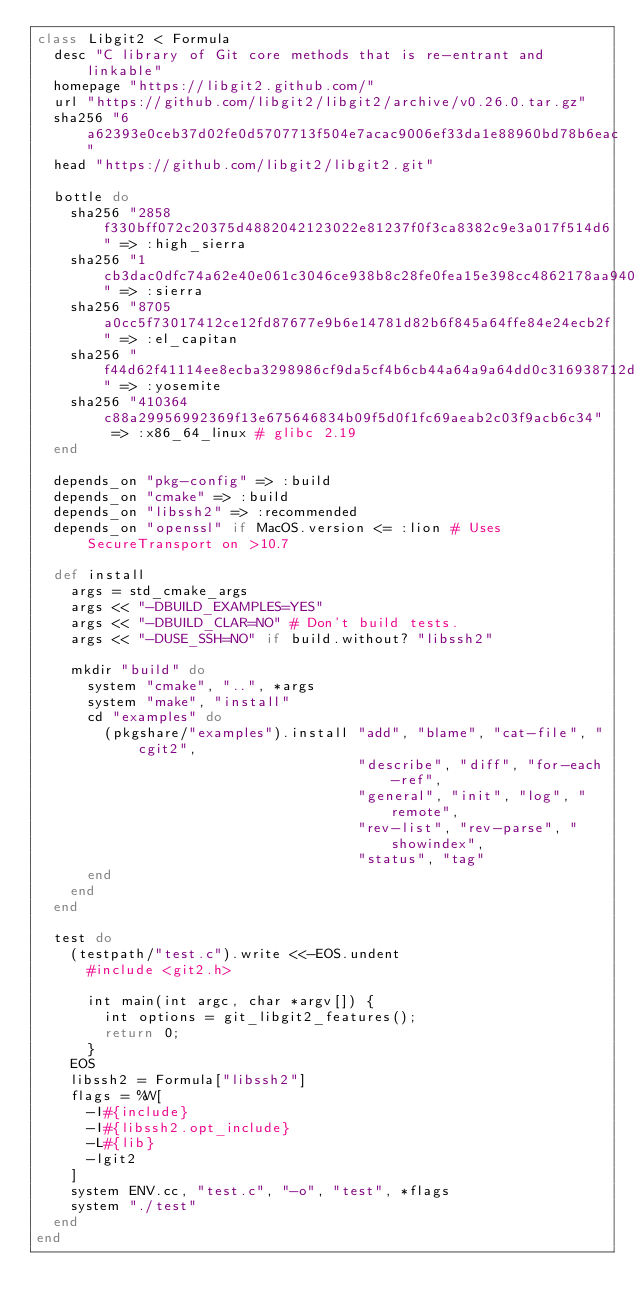Convert code to text. <code><loc_0><loc_0><loc_500><loc_500><_Ruby_>class Libgit2 < Formula
  desc "C library of Git core methods that is re-entrant and linkable"
  homepage "https://libgit2.github.com/"
  url "https://github.com/libgit2/libgit2/archive/v0.26.0.tar.gz"
  sha256 "6a62393e0ceb37d02fe0d5707713f504e7acac9006ef33da1e88960bd78b6eac"
  head "https://github.com/libgit2/libgit2.git"

  bottle do
    sha256 "2858f330bff072c20375d4882042123022e81237f0f3ca8382c9e3a017f514d6" => :high_sierra
    sha256 "1cb3dac0dfc74a62e40e061c3046ce938b8c28fe0fea15e398cc4862178aa940" => :sierra
    sha256 "8705a0cc5f73017412ce12fd87677e9b6e14781d82b6f845a64ffe84e24ecb2f" => :el_capitan
    sha256 "f44d62f41114ee8ecba3298986cf9da5cf4b6cb44a64a9a64dd0c316938712d1" => :yosemite
    sha256 "410364c88a29956992369f13e675646834b09f5d0f1fc69aeab2c03f9acb6c34" => :x86_64_linux # glibc 2.19
  end

  depends_on "pkg-config" => :build
  depends_on "cmake" => :build
  depends_on "libssh2" => :recommended
  depends_on "openssl" if MacOS.version <= :lion # Uses SecureTransport on >10.7

  def install
    args = std_cmake_args
    args << "-DBUILD_EXAMPLES=YES"
    args << "-DBUILD_CLAR=NO" # Don't build tests.
    args << "-DUSE_SSH=NO" if build.without? "libssh2"

    mkdir "build" do
      system "cmake", "..", *args
      system "make", "install"
      cd "examples" do
        (pkgshare/"examples").install "add", "blame", "cat-file", "cgit2",
                                      "describe", "diff", "for-each-ref",
                                      "general", "init", "log", "remote",
                                      "rev-list", "rev-parse", "showindex",
                                      "status", "tag"
      end
    end
  end

  test do
    (testpath/"test.c").write <<-EOS.undent
      #include <git2.h>

      int main(int argc, char *argv[]) {
        int options = git_libgit2_features();
        return 0;
      }
    EOS
    libssh2 = Formula["libssh2"]
    flags = %W[
      -I#{include}
      -I#{libssh2.opt_include}
      -L#{lib}
      -lgit2
    ]
    system ENV.cc, "test.c", "-o", "test", *flags
    system "./test"
  end
end
</code> 